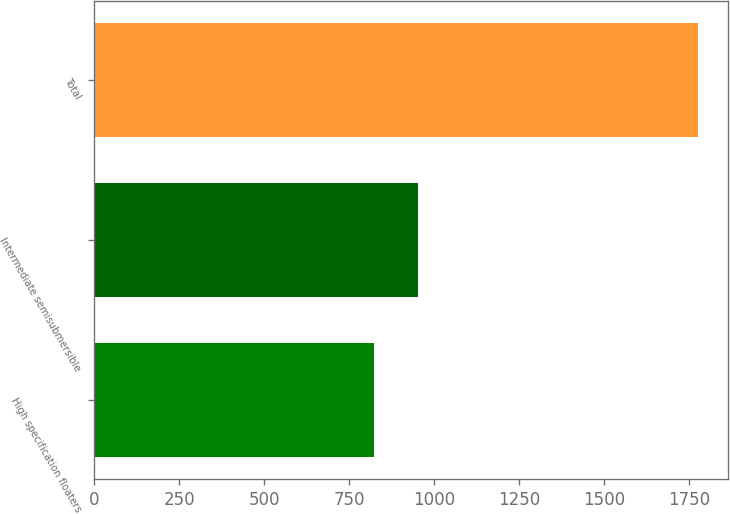Convert chart. <chart><loc_0><loc_0><loc_500><loc_500><bar_chart><fcel>High specification floaters<fcel>Intermediate semisubmersible<fcel>Total<nl><fcel>822<fcel>953<fcel>1775<nl></chart> 